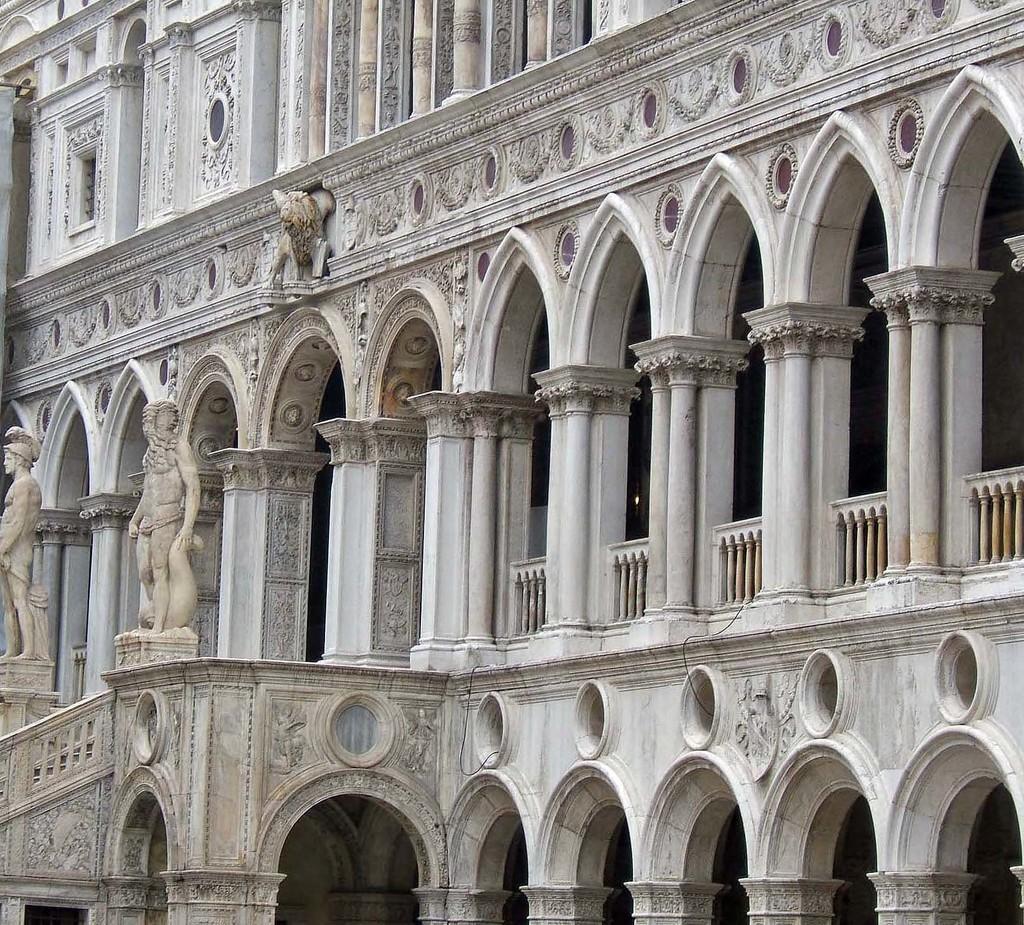Can you describe this image briefly? In the picture there is a building, on the building there are arches present, there are statues present. 